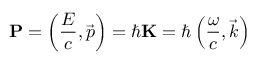<formula> <loc_0><loc_0><loc_500><loc_500>P = \left ( { \frac { E } { c } } , { \vec { p } } \right ) = \hbar { K } = \hbar { \left } ( { \frac { \omega } { c } } , { \vec { k } } \right )</formula> 